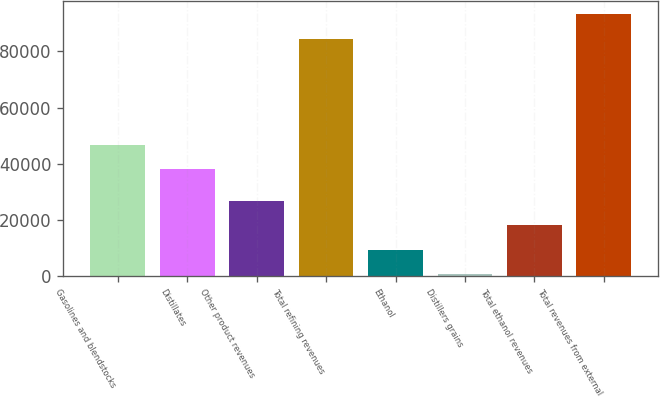Convert chart to OTSL. <chart><loc_0><loc_0><loc_500><loc_500><bar_chart><fcel>Gasolines and blendstocks<fcel>Distillates<fcel>Other product revenues<fcel>Total refining revenues<fcel>Ethanol<fcel>Distillers grains<fcel>Total ethanol revenues<fcel>Total revenues from external<nl><fcel>46807.9<fcel>38093<fcel>26799.7<fcel>84521<fcel>9369.9<fcel>655<fcel>18084.8<fcel>93235.9<nl></chart> 